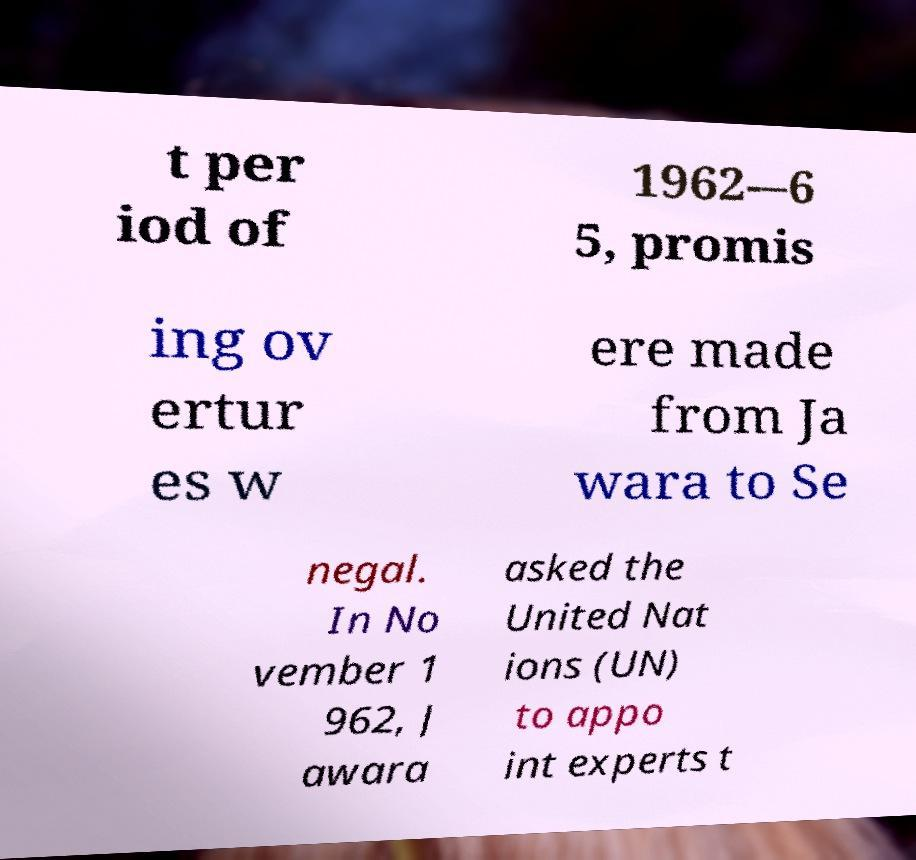Please identify and transcribe the text found in this image. t per iod of 1962-–6 5, promis ing ov ertur es w ere made from Ja wara to Se negal. In No vember 1 962, J awara asked the United Nat ions (UN) to appo int experts t 